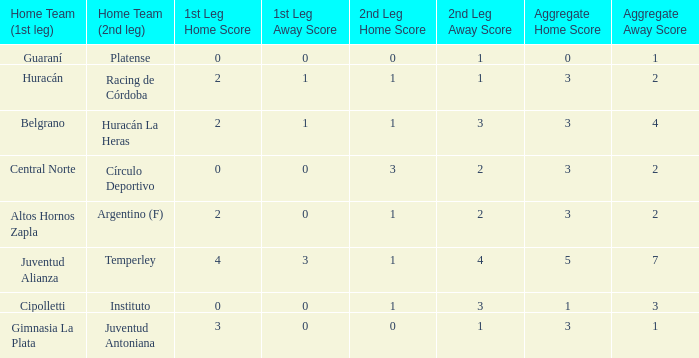Who played at home for the 2nd leg with a score of 1-2? Argentino (F). 